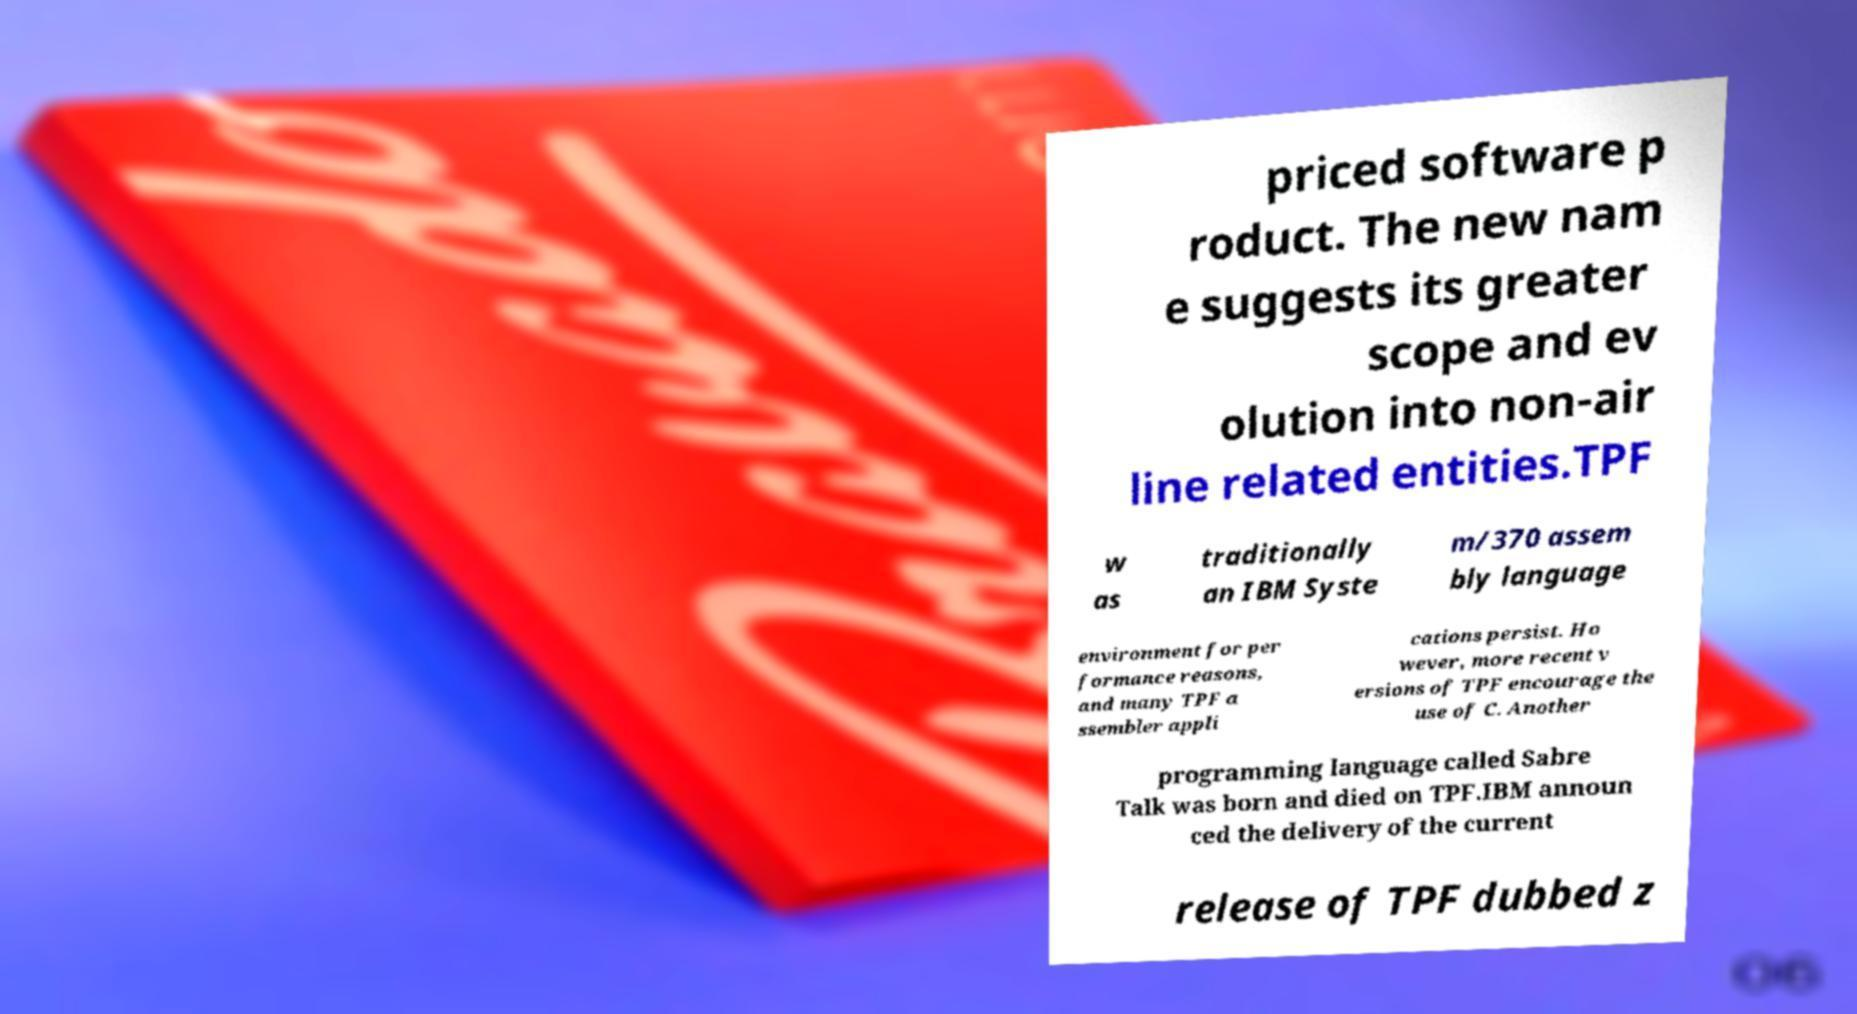What messages or text are displayed in this image? I need them in a readable, typed format. priced software p roduct. The new nam e suggests its greater scope and ev olution into non-air line related entities.TPF w as traditionally an IBM Syste m/370 assem bly language environment for per formance reasons, and many TPF a ssembler appli cations persist. Ho wever, more recent v ersions of TPF encourage the use of C. Another programming language called Sabre Talk was born and died on TPF.IBM announ ced the delivery of the current release of TPF dubbed z 